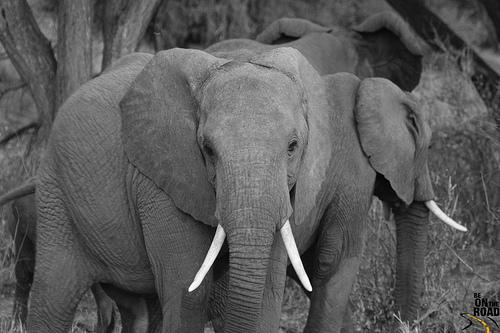Question: who is the picture?
Choices:
A. Dogs.
B. Cats.
C. Cows.
D. Elephants.
Answer with the letter. Answer: D Question: how many elephants are in the picture?
Choices:
A. 1.
B. 2.
C. 3.
D. 4.
Answer with the letter. Answer: C Question: what color are the tusks?
Choices:
A. White.
B. Red.
C. Blue.
D. Green.
Answer with the letter. Answer: A Question: what direction is the middle elephant facing?
Choices:
A. Left.
B. Right.
C. Forward.
D. Backward.
Answer with the letter. Answer: B Question: how many tusks do you see?
Choices:
A. 1.
B. 3.
C. 2.
D. 4.
Answer with the letter. Answer: B 